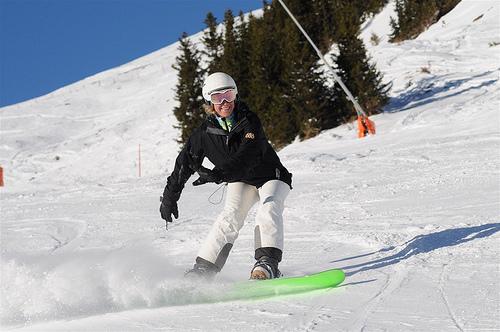How many people are in this scene?
Answer briefly. 1. What is covering the skiers eyes?
Give a very brief answer. Goggles. What sport is this?
Be succinct. Snowboarding. What is on his feet?
Give a very brief answer. Snowboard. What is written on the bottom of the snowboard?
Write a very short answer. Nothing. What sport is being performed here?
Keep it brief. Snowboarding. Is a shadow cast?
Give a very brief answer. Yes. What are these people doing on the snow?
Keep it brief. Snowboarding. What is the person doing?
Keep it brief. Snowboarding. What is the snowboarder wearing on their head?
Answer briefly. Helmet. What is in the background?
Keep it brief. Trees. Is this man snowboarding?
Write a very short answer. Yes. Is the snowboarder going to sit down?
Be succinct. No. 